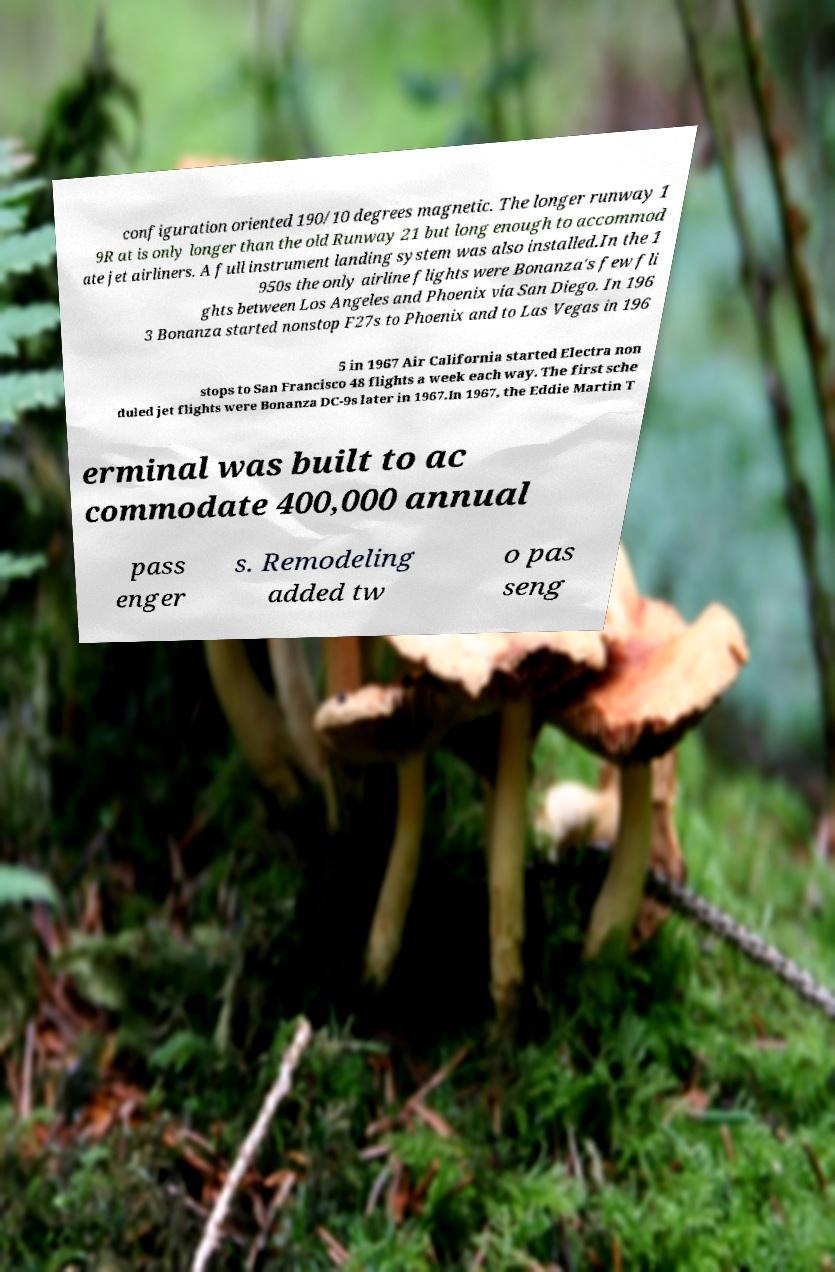I need the written content from this picture converted into text. Can you do that? configuration oriented 190/10 degrees magnetic. The longer runway 1 9R at is only longer than the old Runway 21 but long enough to accommod ate jet airliners. A full instrument landing system was also installed.In the 1 950s the only airline flights were Bonanza's few fli ghts between Los Angeles and Phoenix via San Diego. In 196 3 Bonanza started nonstop F27s to Phoenix and to Las Vegas in 196 5 in 1967 Air California started Electra non stops to San Francisco 48 flights a week each way. The first sche duled jet flights were Bonanza DC-9s later in 1967.In 1967, the Eddie Martin T erminal was built to ac commodate 400,000 annual pass enger s. Remodeling added tw o pas seng 